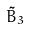<formula> <loc_0><loc_0><loc_500><loc_500>\tilde { B } _ { 3 }</formula> 